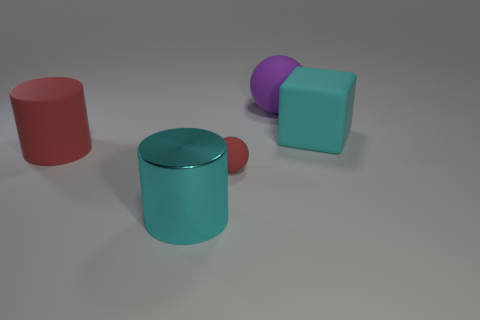What color is the large ball?
Provide a succinct answer. Purple. The thing that is in front of the big red cylinder and behind the large cyan cylinder is made of what material?
Offer a terse response. Rubber. There is a large object on the left side of the large cylinder that is in front of the tiny rubber thing; are there any small red spheres left of it?
Your response must be concise. No. There is a rubber block that is the same color as the shiny object; what size is it?
Ensure brevity in your answer.  Large. Are there any tiny red balls right of the large purple matte ball?
Give a very brief answer. No. What number of other things are there of the same shape as the purple matte thing?
Your answer should be compact. 1. There is a matte cylinder that is the same size as the cyan rubber thing; what color is it?
Keep it short and to the point. Red. Are there fewer large rubber things that are in front of the large purple sphere than rubber balls that are behind the red matte cylinder?
Provide a short and direct response. No. What number of large purple objects are on the left side of the matte ball left of the rubber sphere that is behind the big red thing?
Provide a succinct answer. 0. What size is the other object that is the same shape as the purple object?
Offer a very short reply. Small. 